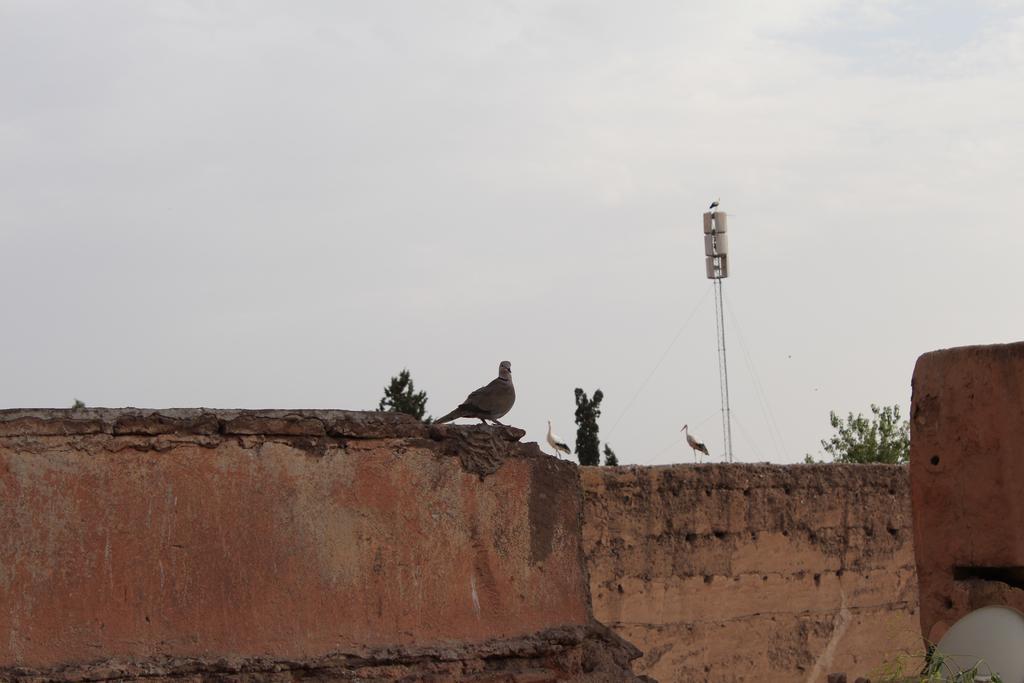Can you describe this image briefly? In this picture we can see birds on the wall, trees, pole and in the background we can see the sky. 